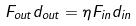<formula> <loc_0><loc_0><loc_500><loc_500>F _ { o u t } d _ { o u t } = \eta F _ { i n } d _ { i n }</formula> 